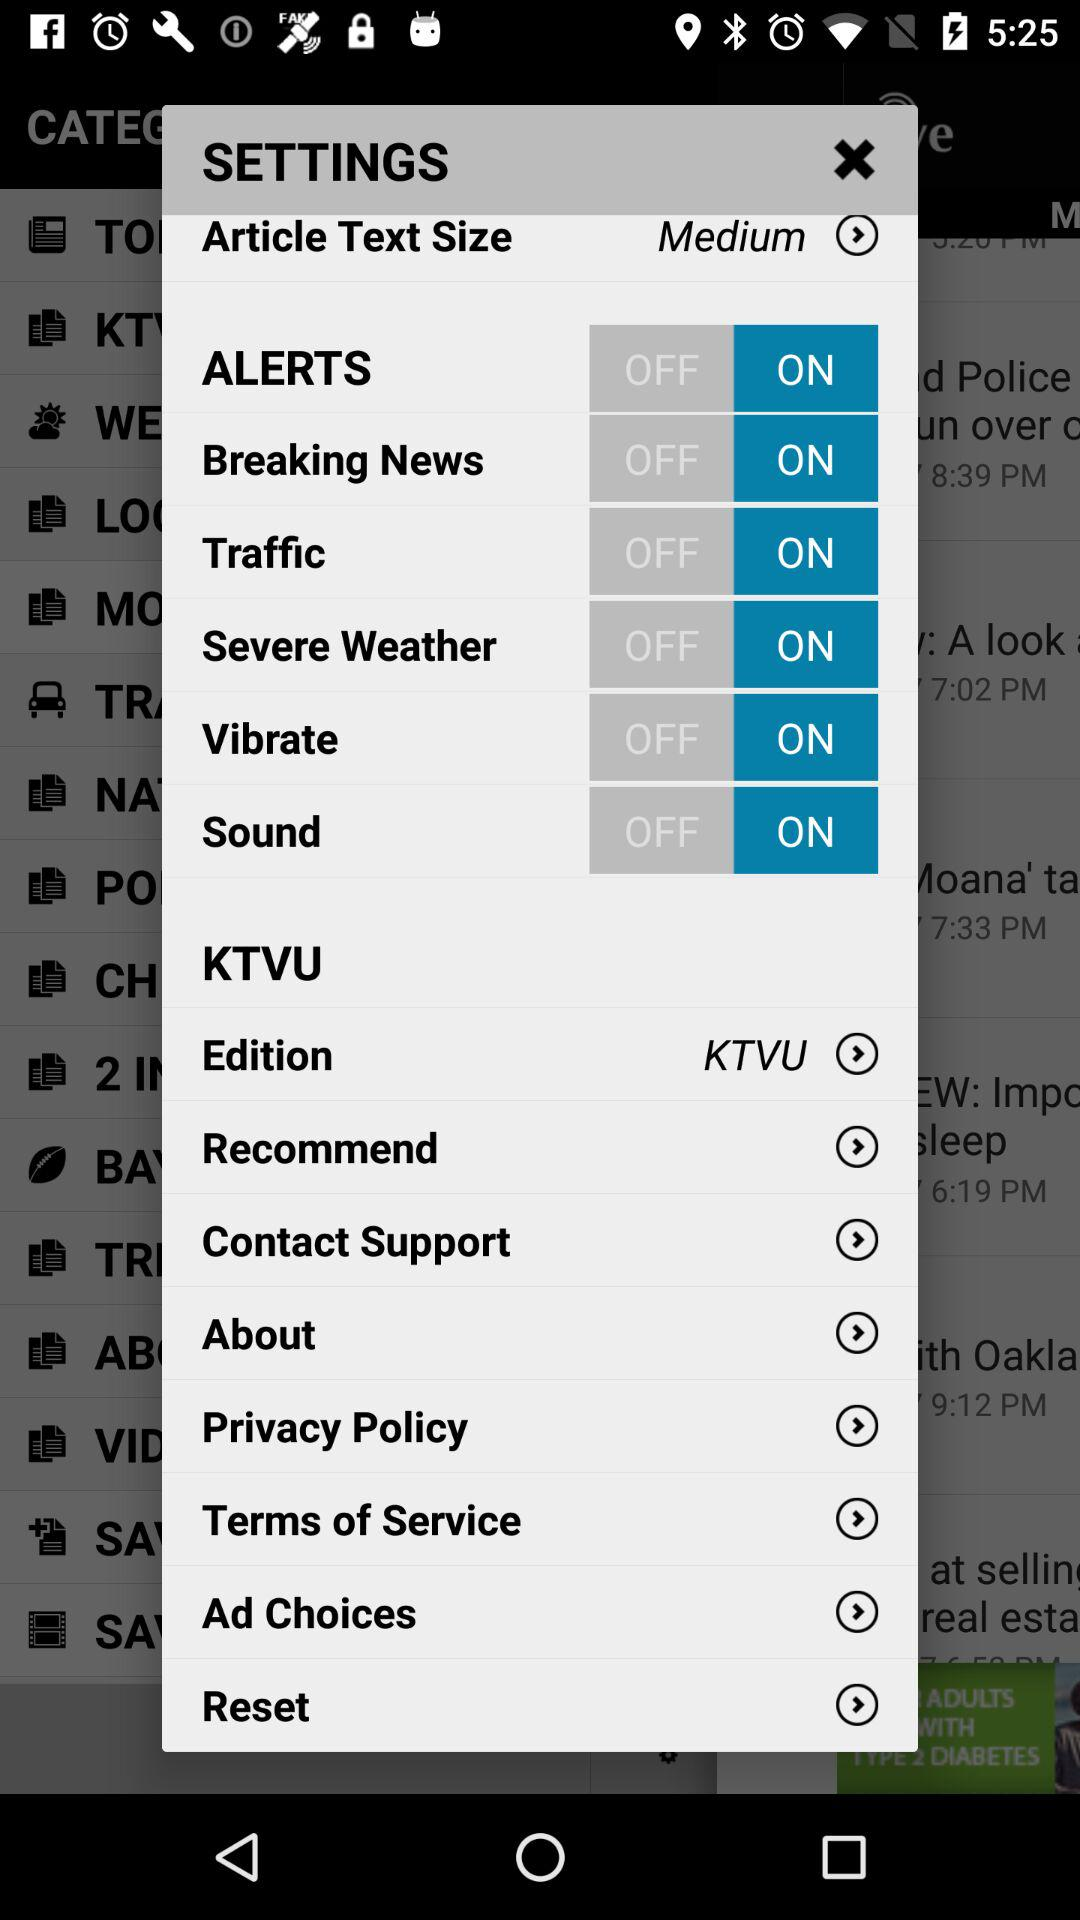Which email address is used to contact support?
When the provided information is insufficient, respond with <no answer>. <no answer> 